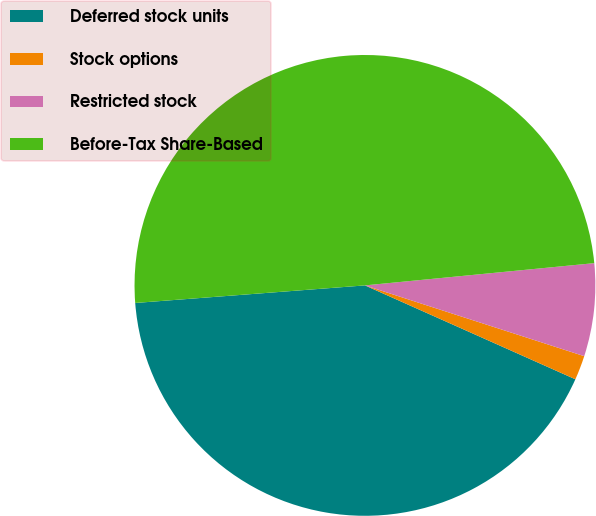<chart> <loc_0><loc_0><loc_500><loc_500><pie_chart><fcel>Deferred stock units<fcel>Stock options<fcel>Restricted stock<fcel>Before-Tax Share-Based<nl><fcel>42.11%<fcel>1.71%<fcel>6.51%<fcel>49.68%<nl></chart> 